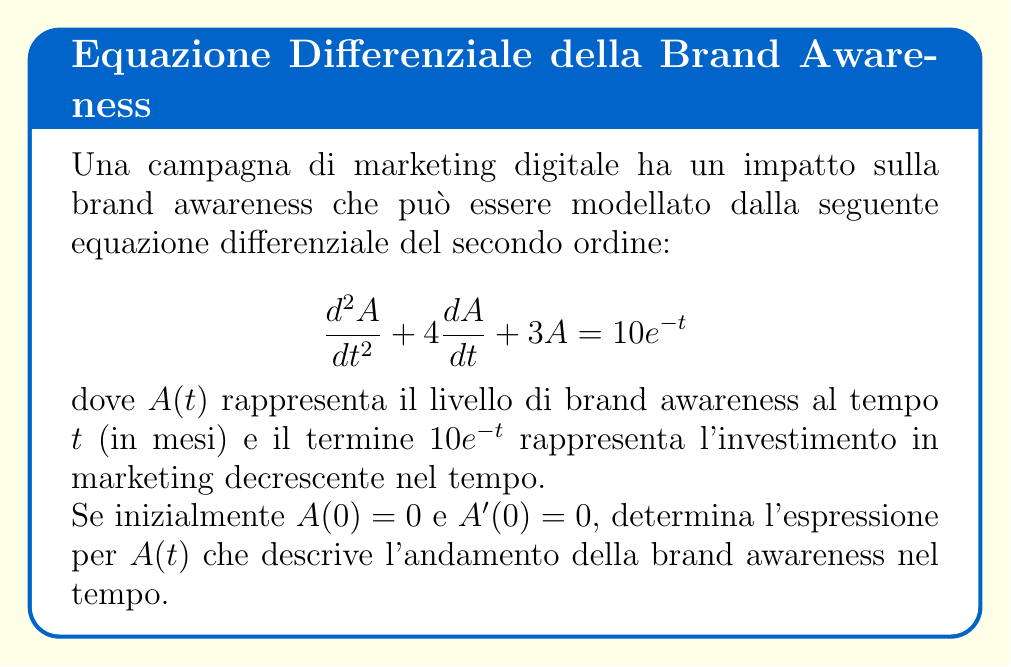Can you answer this question? Per risolvere questa equazione differenziale, seguiamo questi passaggi:

1) L'equazione è non omogenea, quindi la soluzione generale sarà la somma della soluzione dell'equazione omogenea e di una soluzione particolare.

2) Per l'equazione omogenea $\frac{d^2A}{dt^2} + 4\frac{dA}{dt} + 3A = 0$:
   L'equazione caratteristica è $r^2 + 4r + 3 = 0$
   Le radici sono $r_1 = -1$ e $r_2 = -3$
   Quindi, la soluzione omogenea è $A_h(t) = c_1e^{-t} + c_2e^{-3t}$

3) Per la soluzione particolare, usiamo il metodo dei coefficienti indeterminati:
   Supponiamo $A_p(t) = kt e^{-t}$
   Sostituendo nell'equazione originale e risolvendo per $k$, otteniamo $k = 2$
   Quindi, $A_p(t) = 2t e^{-t}$

4) La soluzione generale è $A(t) = A_h(t) + A_p(t) = c_1e^{-t} + c_2e^{-3t} + 2t e^{-t}$

5) Usando le condizioni iniziali:
   $A(0) = 0$ implica $c_1 + c_2 = 0$
   $A'(0) = 0$ implica $-c_1 - 3c_2 + 2 = 0$

6) Risolvendo il sistema di equazioni:
   $c_1 = 1$ e $c_2 = -1$

7) Quindi, la soluzione finale è:
   $A(t) = e^{-t} - e^{-3t} + 2t e^{-t}$
Answer: $A(t) = e^{-t} - e^{-3t} + 2t e^{-t}$ 